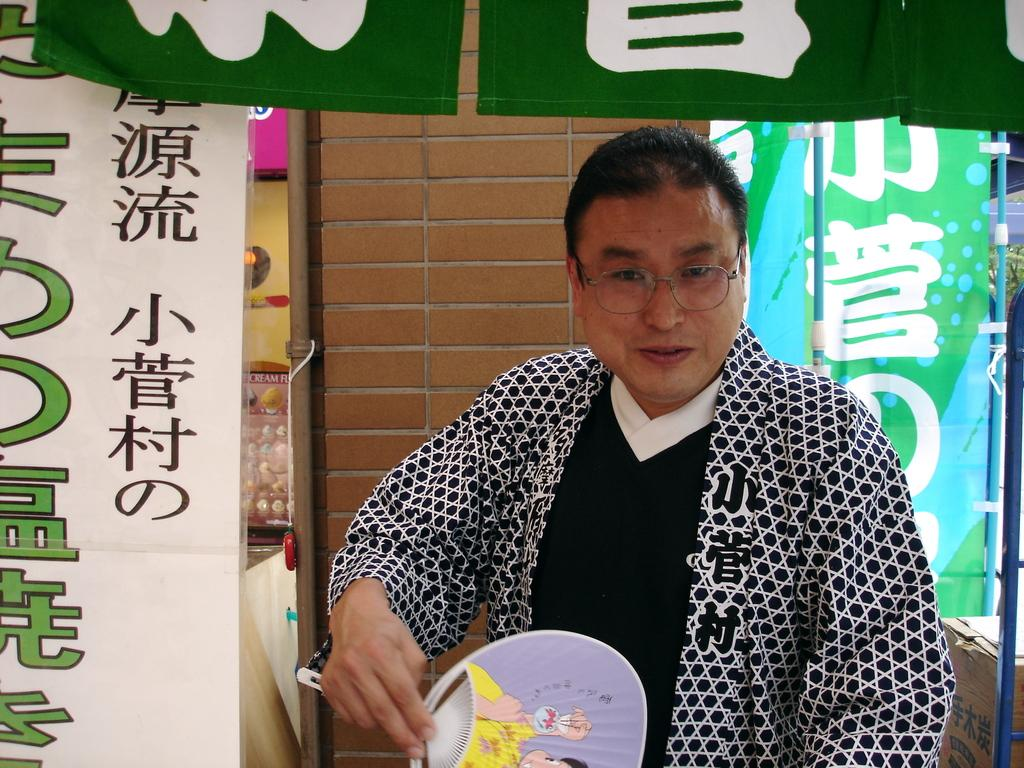Who is present in the image? There is a man in the image. What is the man wearing? The man is wearing spectacles. What is the man holding in the image? The man is holding a hand fan. What is the man's facial expression? The man is smiling. What can be seen in the background of the image? There is a wall, banners, poles, and some objects in the background of the image. What song is the man singing in the image? There is no indication in the image that the man is singing a song, so it cannot be determined from the picture. 